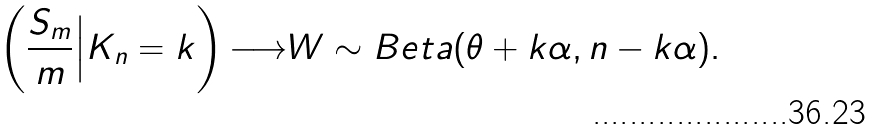<formula> <loc_0><loc_0><loc_500><loc_500>\left ( \frac { S _ { m } } { m } \Big | K _ { n } = k \right ) { \longrightarrow } W \sim B e t a ( \theta + k \alpha , n - k \alpha ) .</formula> 